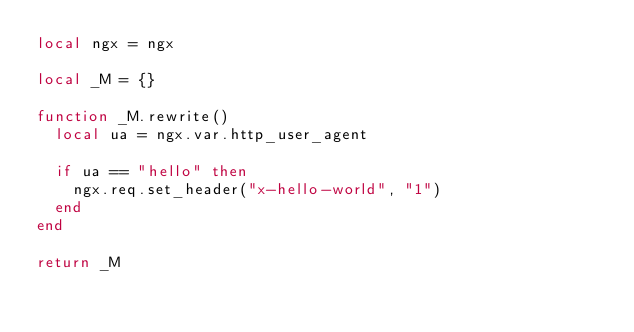Convert code to text. <code><loc_0><loc_0><loc_500><loc_500><_Lua_>local ngx = ngx

local _M = {}

function _M.rewrite()
  local ua = ngx.var.http_user_agent

  if ua == "hello" then
    ngx.req.set_header("x-hello-world", "1")
  end
end

return _M
</code> 